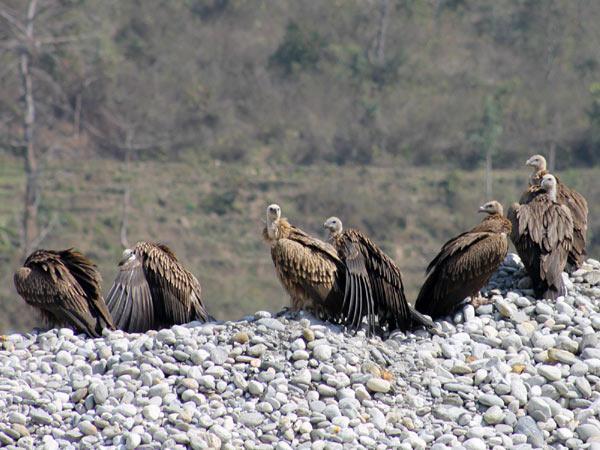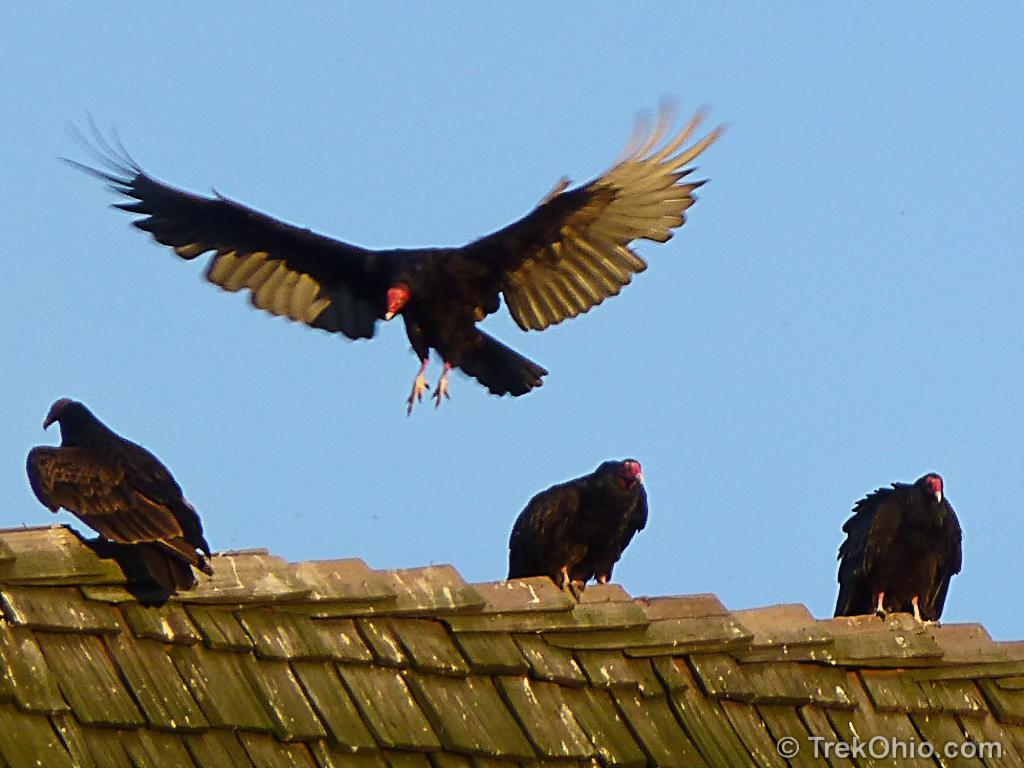The first image is the image on the left, the second image is the image on the right. Analyze the images presented: Is the assertion "There are no more than five birds in one of the images." valid? Answer yes or no. Yes. 